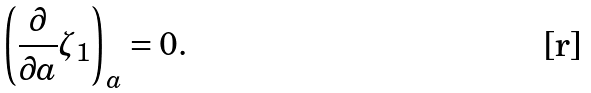<formula> <loc_0><loc_0><loc_500><loc_500>\left ( \frac { \partial } { \partial a } \zeta _ { 1 } \right ) _ { a } = 0 .</formula> 